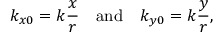<formula> <loc_0><loc_0><loc_500><loc_500>k _ { x 0 } = k \frac { x } { r } \quad a n d \quad k _ { y 0 } = k \frac { y } { r } ,</formula> 